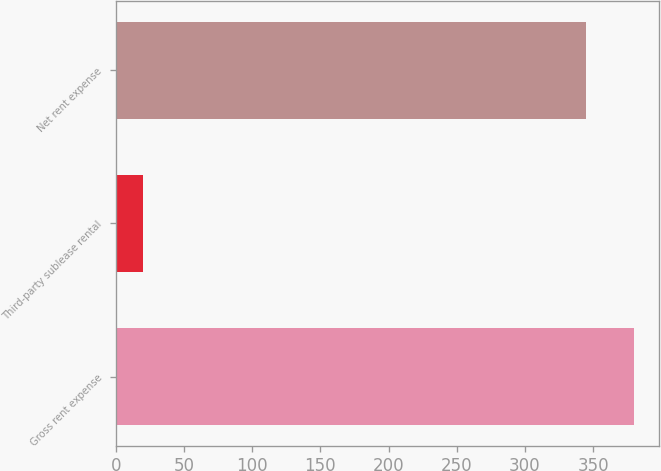<chart> <loc_0><loc_0><loc_500><loc_500><bar_chart><fcel>Gross rent expense<fcel>Third-party sublease rental<fcel>Net rent expense<nl><fcel>379.72<fcel>20<fcel>345.2<nl></chart> 